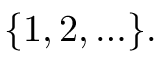Convert formula to latex. <formula><loc_0><loc_0><loc_500><loc_500>\{ 1 , 2 , \dots \} .</formula> 